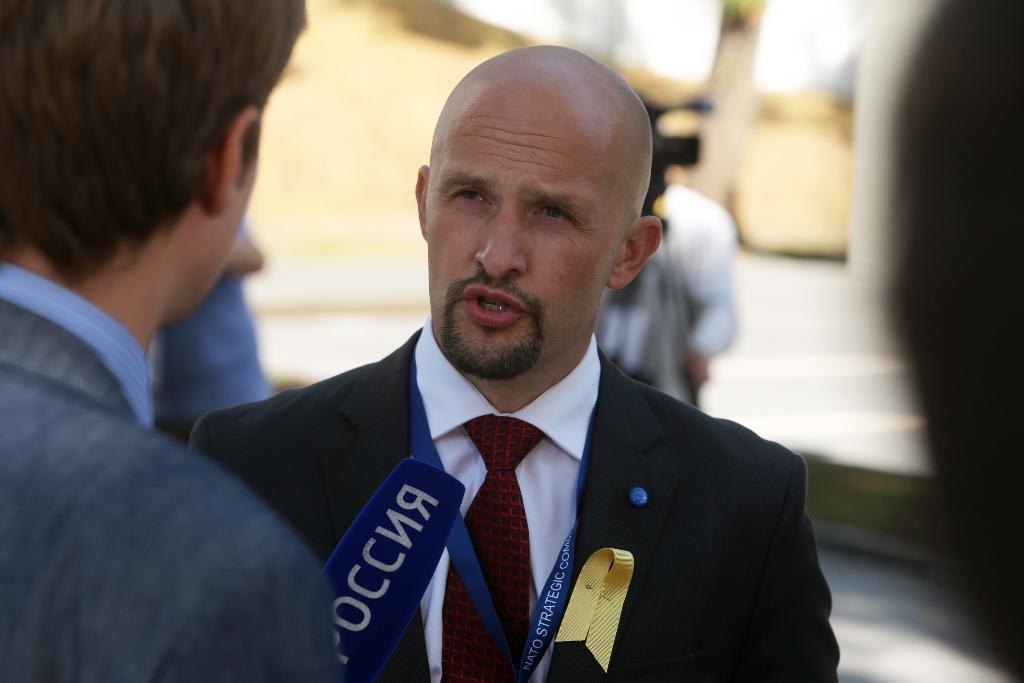Could you give a brief overview of what you see in this image? In this picture we can see a group of people standing and a man in the black blazer is explaining something. In front of the man there is an object. Behind the man there is a camera with the tripod stand. Behind the people there is the blurred background. 